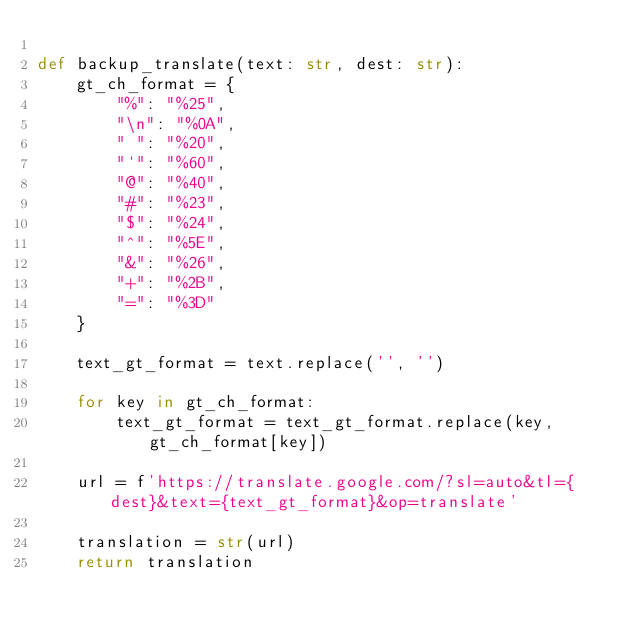<code> <loc_0><loc_0><loc_500><loc_500><_Python_>
def backup_translate(text: str, dest: str):
	gt_ch_format = {
		"%": "%25",
		"\n": "%0A",
		" ": "%20",
		"`": "%60",
		"@": "%40",
		"#": "%23",
		"$": "%24",
		"^": "%5E",
		"&": "%26",
		"+": "%2B",
		"=": "%3D"
	}

	text_gt_format = text.replace('', '')
	
	for key in gt_ch_format:
		text_gt_format = text_gt_format.replace(key, gt_ch_format[key])
	
	url = f'https://translate.google.com/?sl=auto&tl={dest}&text={text_gt_format}&op=translate'
	
	translation = str(url)
	return translation
</code> 